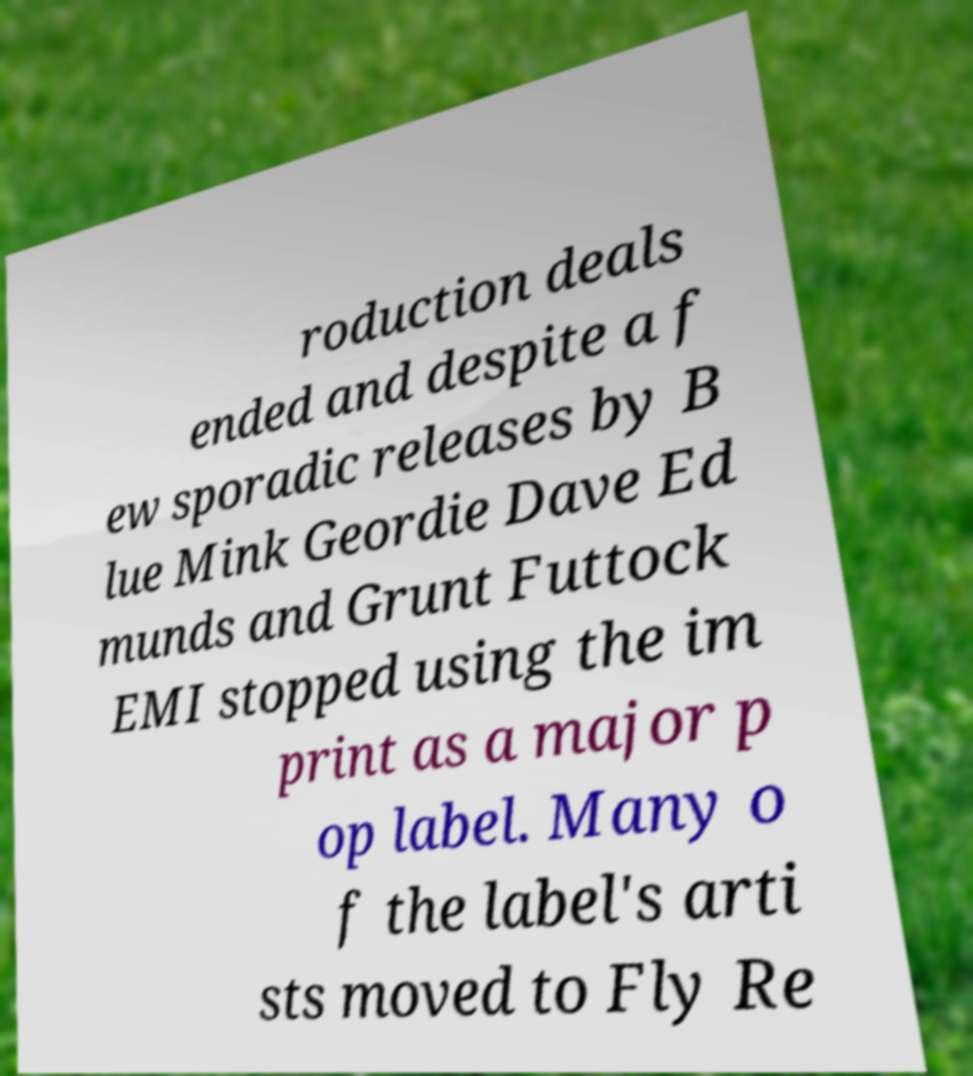I need the written content from this picture converted into text. Can you do that? roduction deals ended and despite a f ew sporadic releases by B lue Mink Geordie Dave Ed munds and Grunt Futtock EMI stopped using the im print as a major p op label. Many o f the label's arti sts moved to Fly Re 